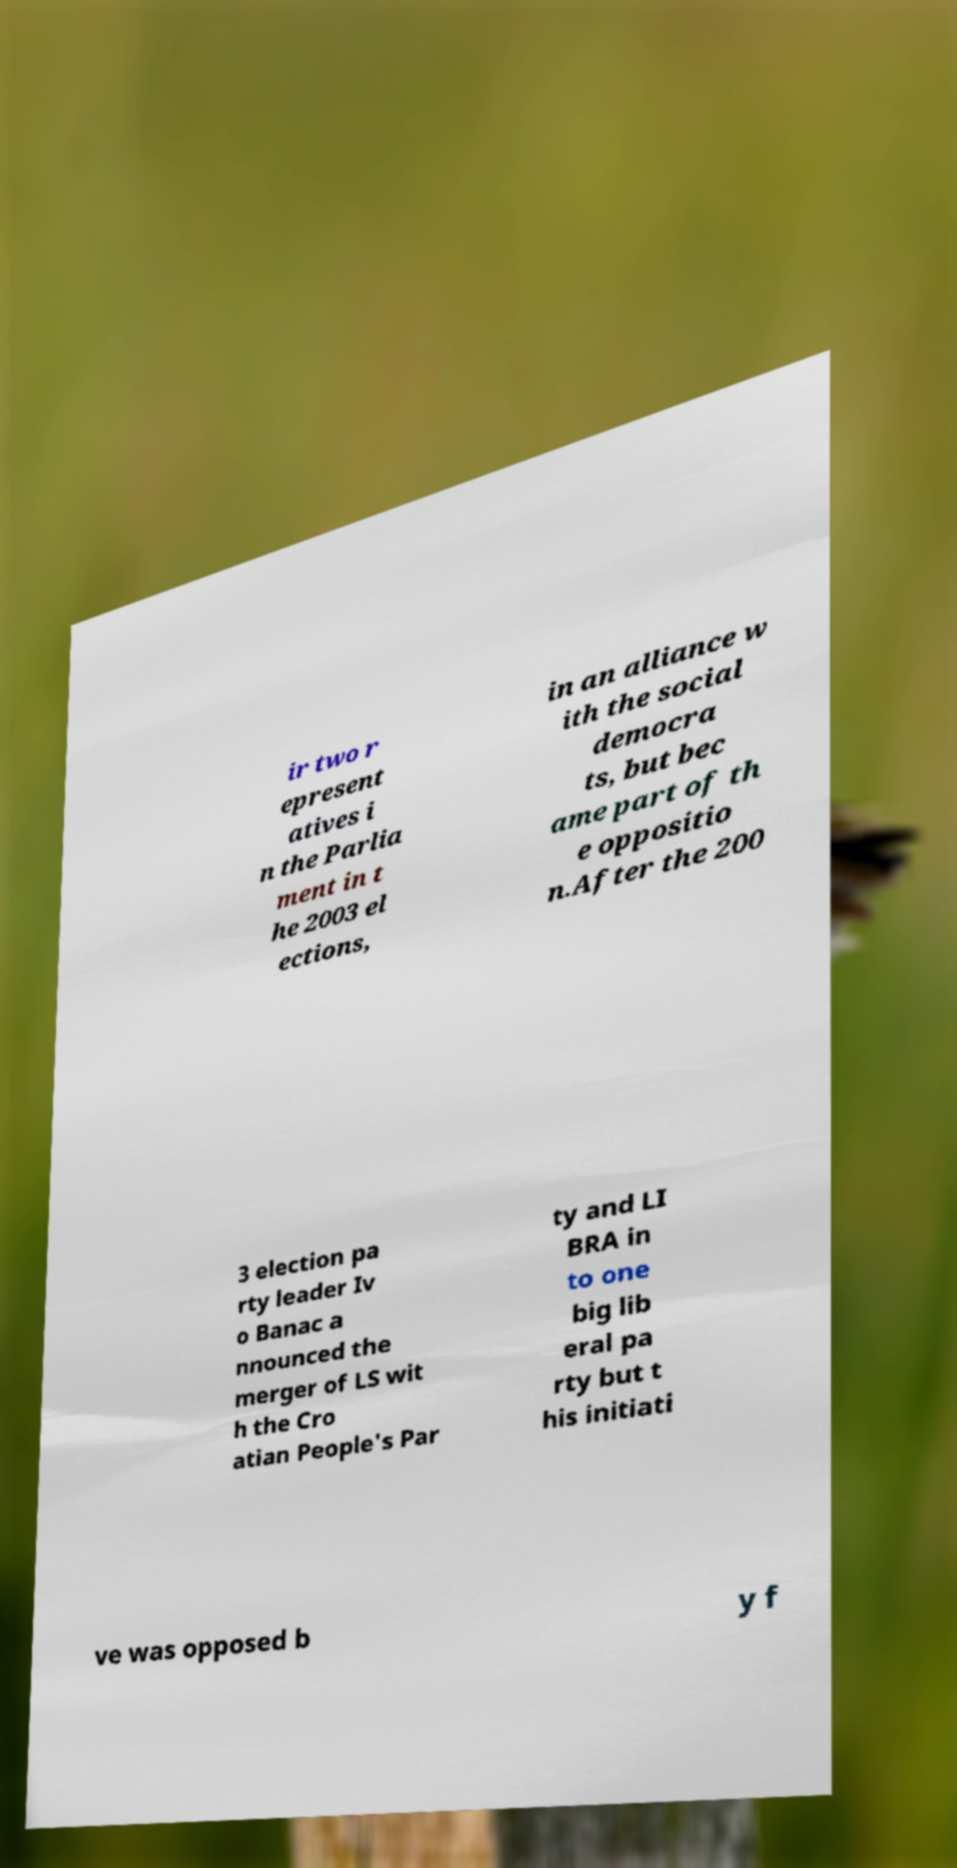Could you assist in decoding the text presented in this image and type it out clearly? ir two r epresent atives i n the Parlia ment in t he 2003 el ections, in an alliance w ith the social democra ts, but bec ame part of th e oppositio n.After the 200 3 election pa rty leader Iv o Banac a nnounced the merger of LS wit h the Cro atian People's Par ty and LI BRA in to one big lib eral pa rty but t his initiati ve was opposed b y f 